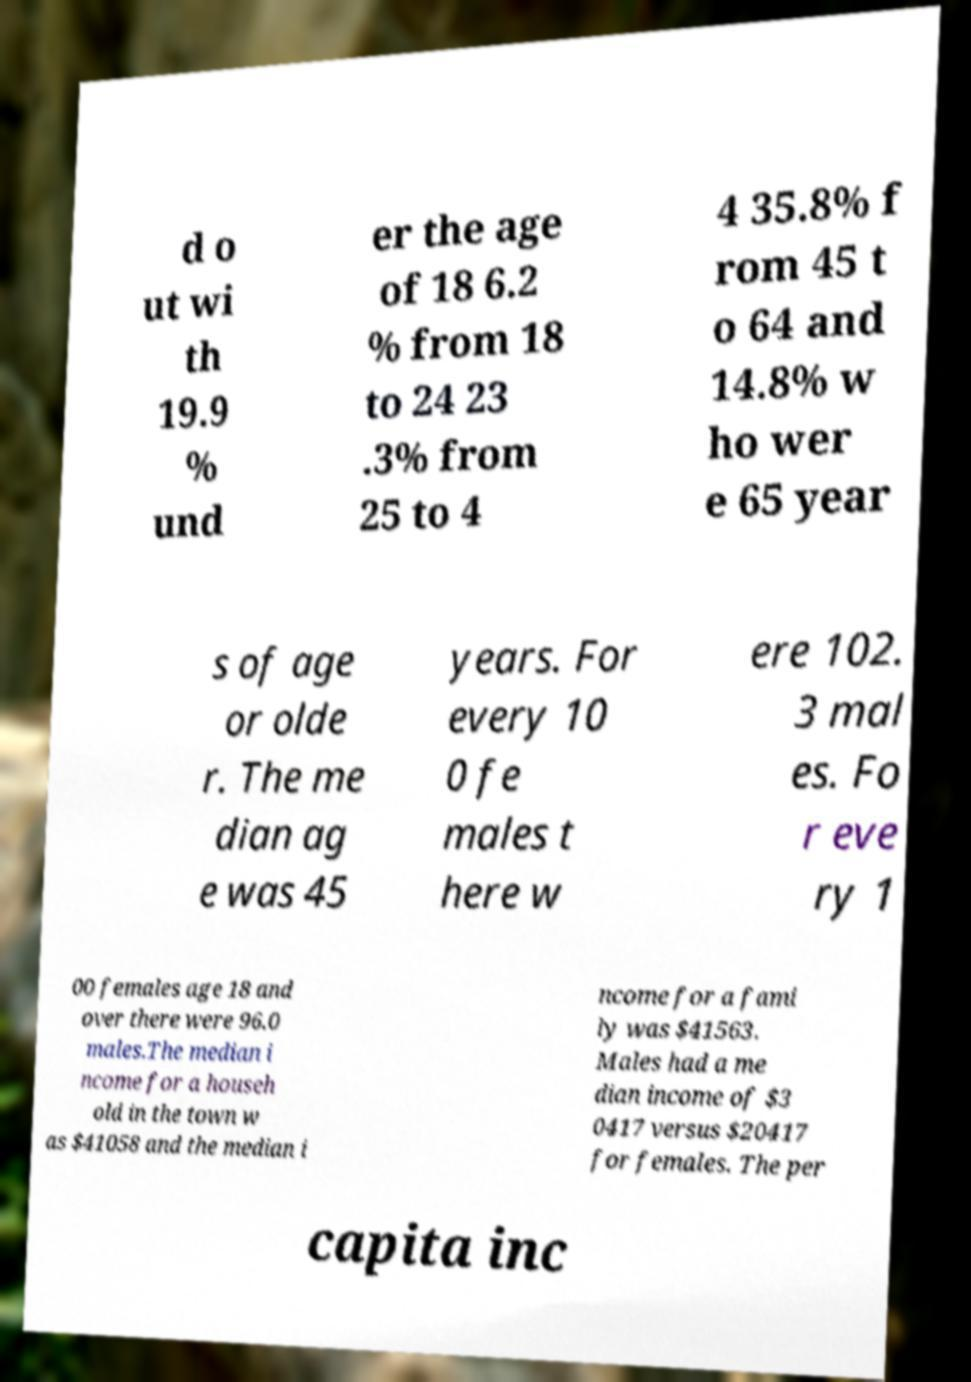What messages or text are displayed in this image? I need them in a readable, typed format. d o ut wi th 19.9 % und er the age of 18 6.2 % from 18 to 24 23 .3% from 25 to 4 4 35.8% f rom 45 t o 64 and 14.8% w ho wer e 65 year s of age or olde r. The me dian ag e was 45 years. For every 10 0 fe males t here w ere 102. 3 mal es. Fo r eve ry 1 00 females age 18 and over there were 96.0 males.The median i ncome for a househ old in the town w as $41058 and the median i ncome for a fami ly was $41563. Males had a me dian income of $3 0417 versus $20417 for females. The per capita inc 